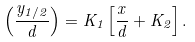Convert formula to latex. <formula><loc_0><loc_0><loc_500><loc_500>\left ( \frac { y _ { 1 / 2 } } { d } \right ) = K _ { 1 } \left [ \frac { x } { d } + K _ { 2 } \right ] .</formula> 